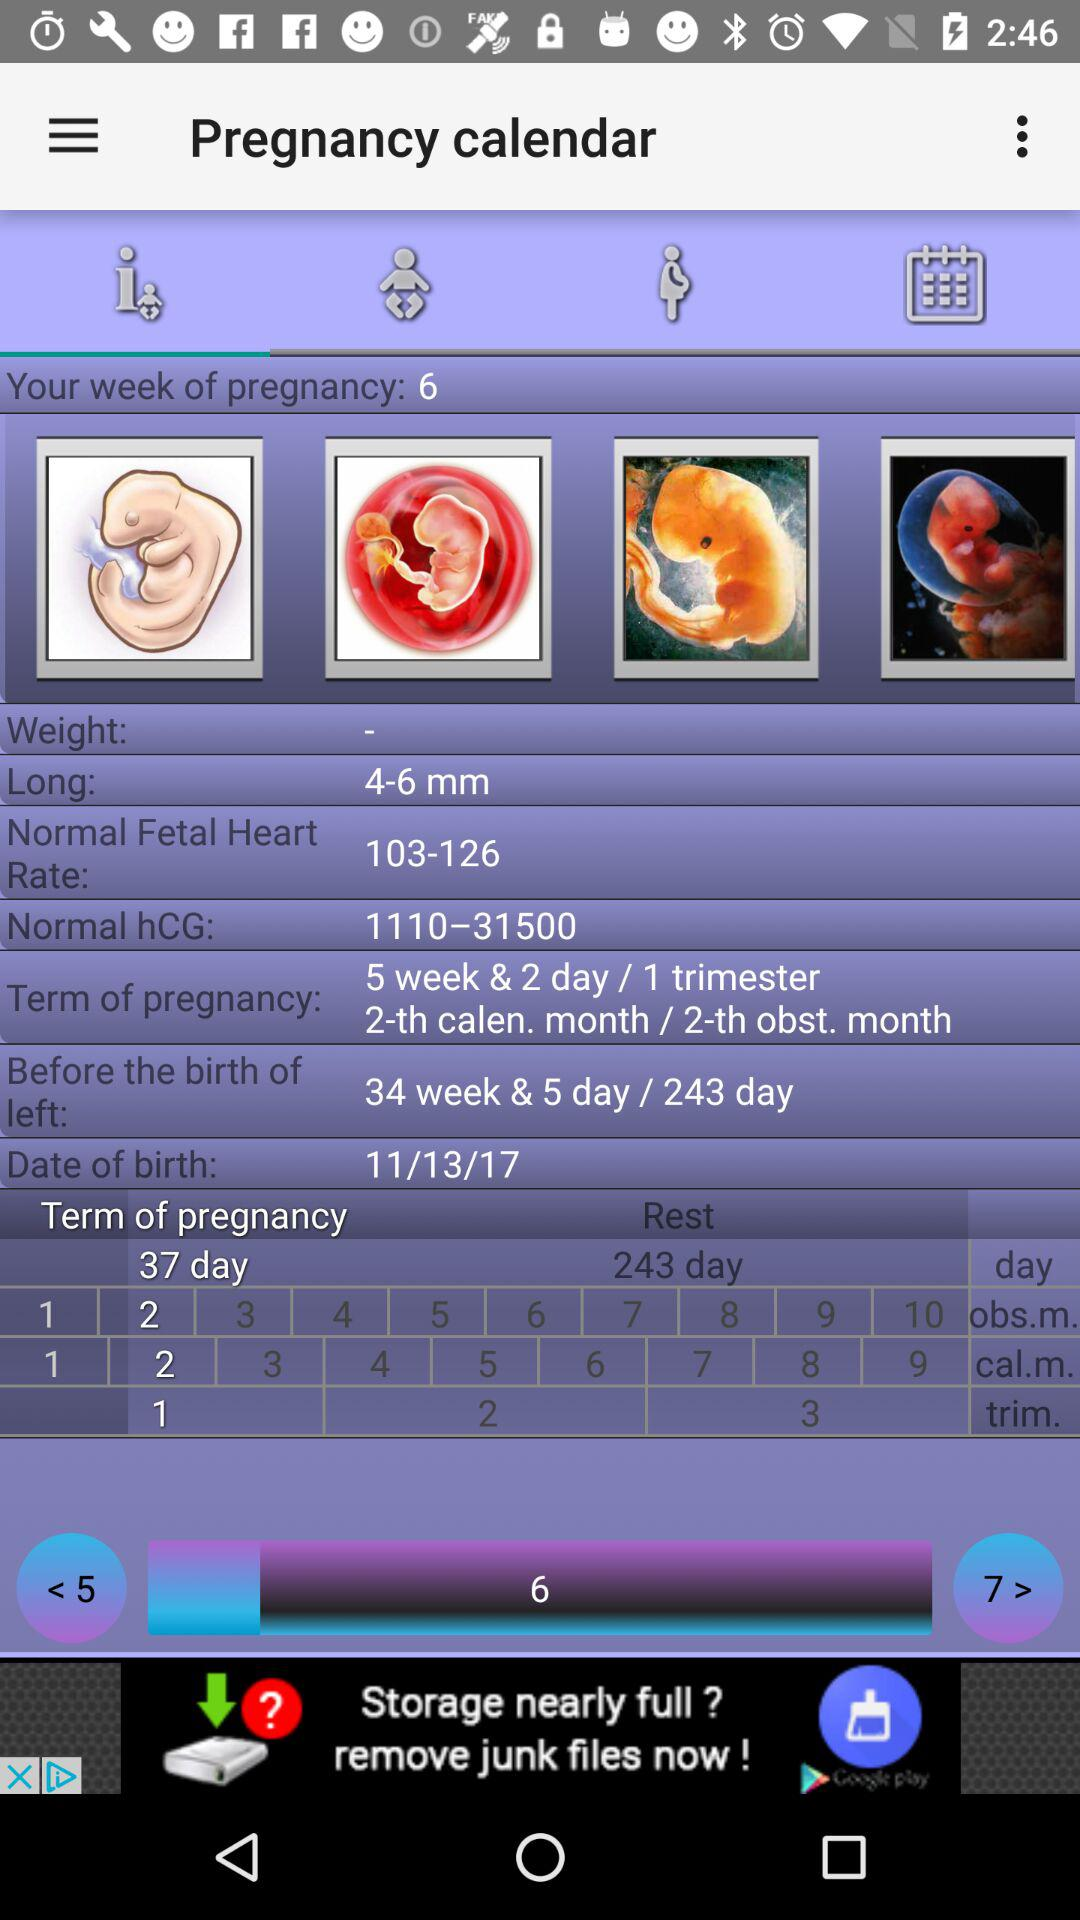How many weeks and days are left before the birth? There are 34 weeks and 5 days left before the birth. 